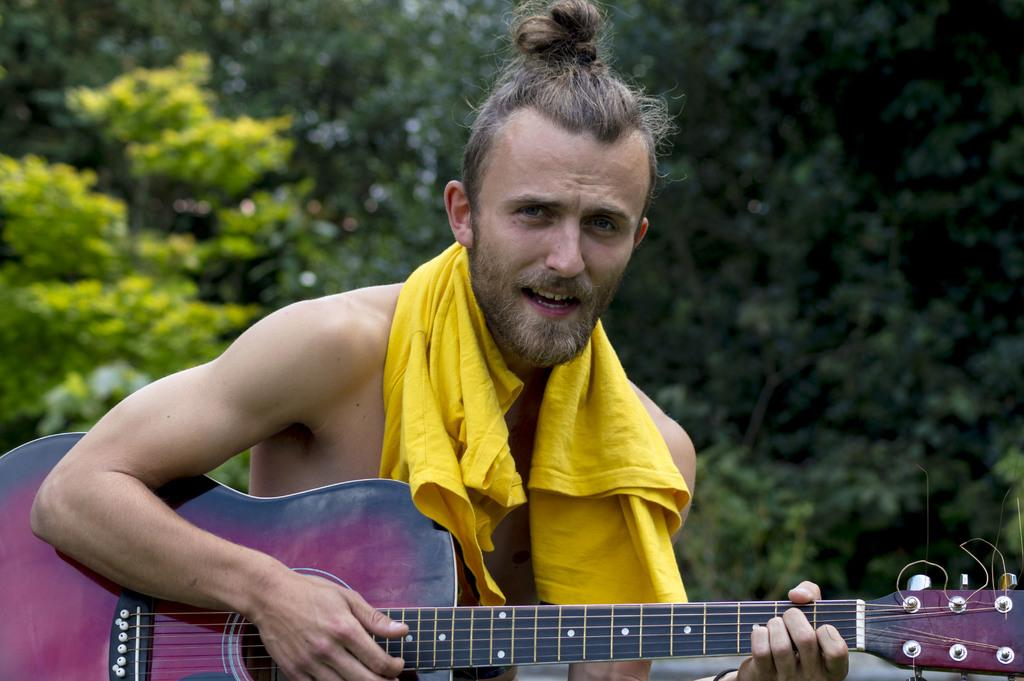Who is present in the image? There is a man in the image. What is the man wearing? The man is wearing a cloth. What is the man holding in the image? The man is holding a guitar. What can be seen in the background of the image? There are trees visible in the background of the image. How many ladybugs can be seen on the guitar in the image? There are no ladybugs present in the image, and the guitar is not mentioned as having any ladybugs on it. 